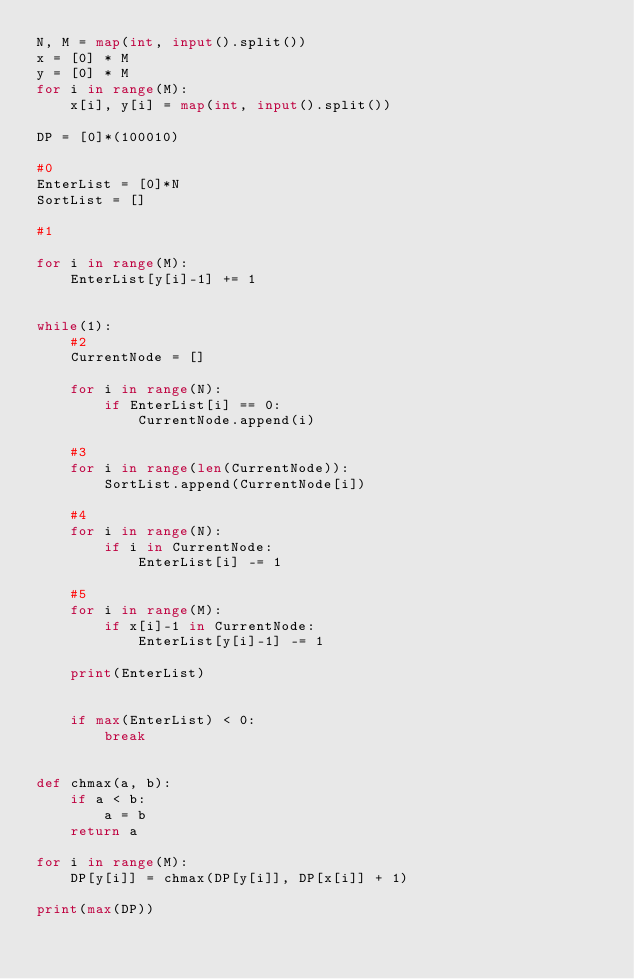<code> <loc_0><loc_0><loc_500><loc_500><_Python_>N, M = map(int, input().split())
x = [0] * M
y = [0] * M
for i in range(M):
    x[i], y[i] = map(int, input().split())

DP = [0]*(100010)

#0
EnterList = [0]*N
SortList = []

#1

for i in range(M):
    EnterList[y[i]-1] += 1


while(1):
    #2
    CurrentNode = []

    for i in range(N):
        if EnterList[i] == 0:
            CurrentNode.append(i)

    #3
    for i in range(len(CurrentNode)):
        SortList.append(CurrentNode[i])

    #4
    for i in range(N):
        if i in CurrentNode:
            EnterList[i] -= 1

    #5
    for i in range(M):
        if x[i]-1 in CurrentNode:
            EnterList[y[i]-1] -= 1

    print(EnterList)


    if max(EnterList) < 0:
        break


def chmax(a, b):
    if a < b:
        a = b
    return a

for i in range(M):
    DP[y[i]] = chmax(DP[y[i]], DP[x[i]] + 1)

print(max(DP))</code> 